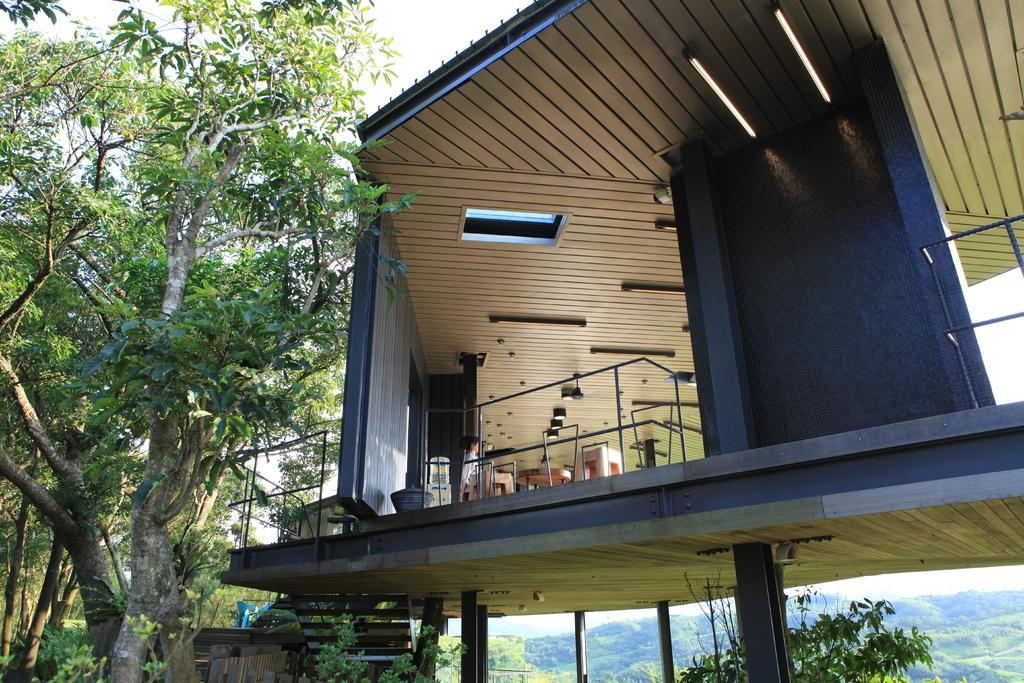What is the main subject of the image? There is a person in the house. What can be seen in the background of the image? There are trees and hills in the background of the image. What is providing illumination in the image? There are lights visible in the image. What type of material is present in the image? There are metal rods in the image. What direction is the person in the image smiling? The image does not show the person smiling, so it cannot be determined in which direction they might be smiling. 